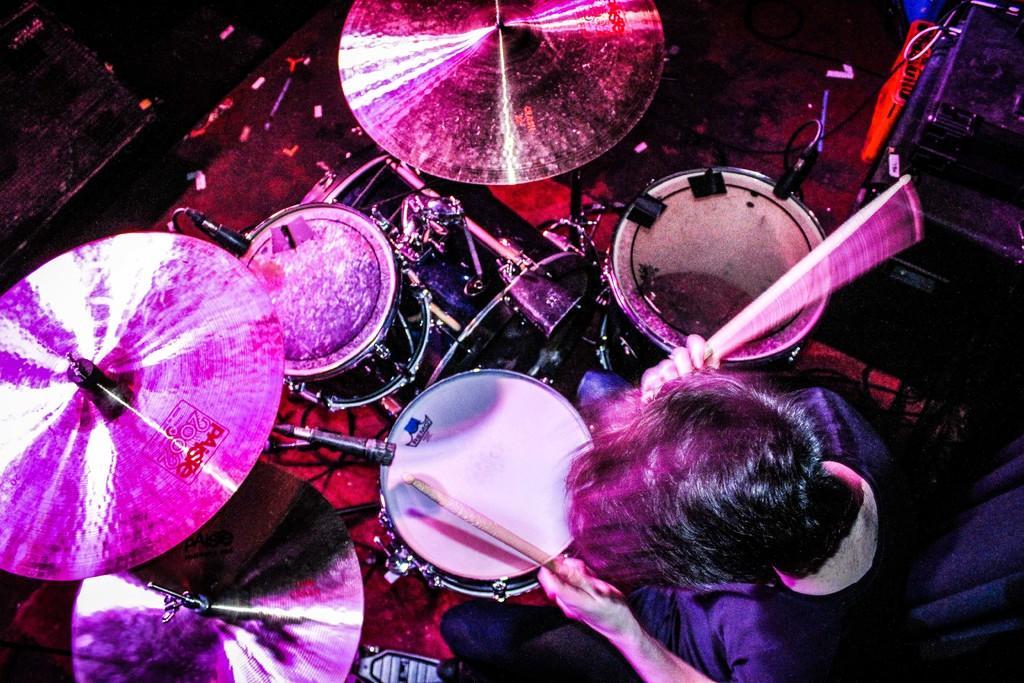How would you summarize this image in a sentence or two? In this image I can see the person sitting and playing the musical instrument. To the side of the person I can see few more objects. And there is a black background. 